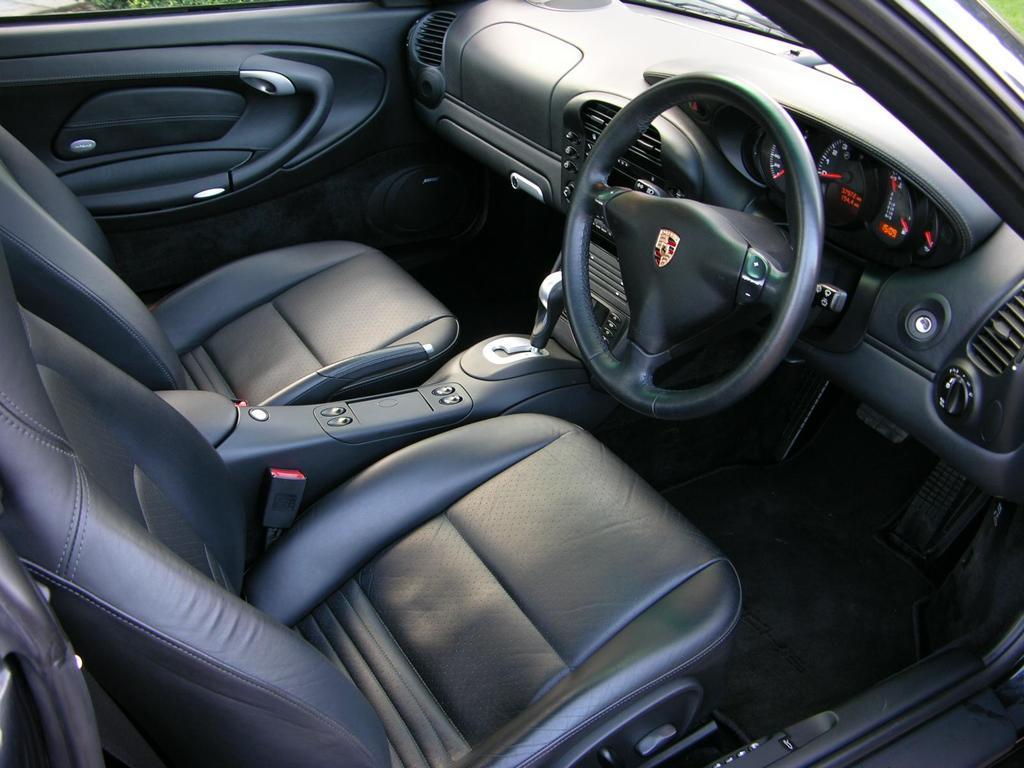In one or two sentences, can you explain what this image depicts? In this picture we can see an inside view of a car, on the right side there is a steering, an amplifier and a gear rod, we can see two seats and a door on the left side. 